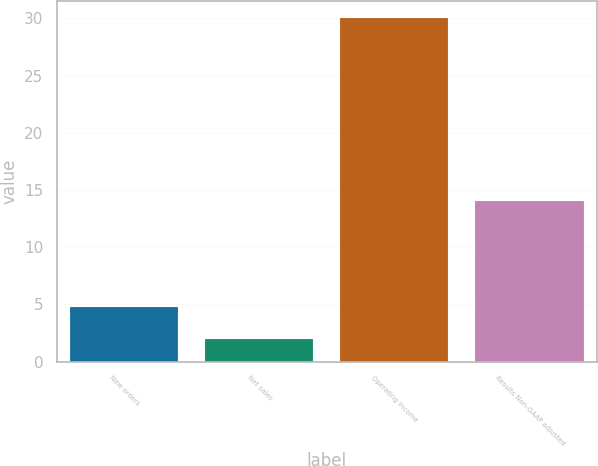Convert chart to OTSL. <chart><loc_0><loc_0><loc_500><loc_500><bar_chart><fcel>New orders<fcel>Net sales<fcel>Operating income<fcel>Results Non-GAAP adjusted<nl><fcel>4.8<fcel>2<fcel>30<fcel>14<nl></chart> 